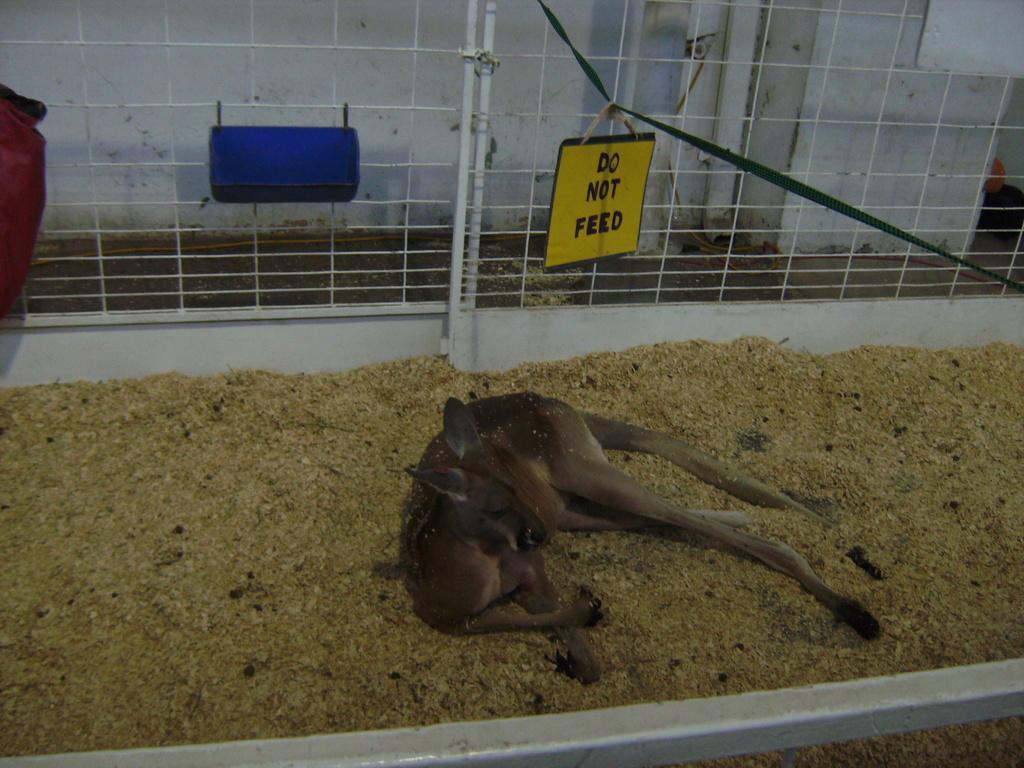In one or two sentences, can you explain what this image depicts? In this image we can see an animal on the ground. Here we can see the pipe, fence and the wall in the background. 